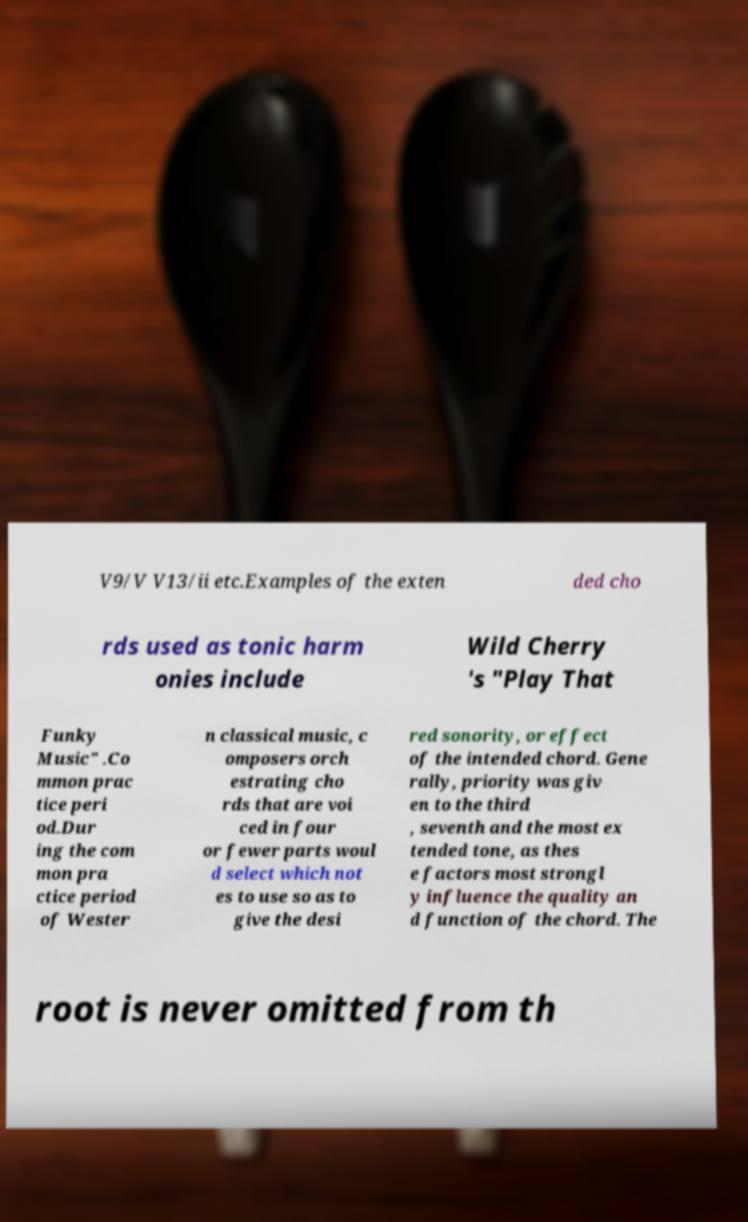What messages or text are displayed in this image? I need them in a readable, typed format. V9/V V13/ii etc.Examples of the exten ded cho rds used as tonic harm onies include Wild Cherry 's "Play That Funky Music" .Co mmon prac tice peri od.Dur ing the com mon pra ctice period of Wester n classical music, c omposers orch estrating cho rds that are voi ced in four or fewer parts woul d select which not es to use so as to give the desi red sonority, or effect of the intended chord. Gene rally, priority was giv en to the third , seventh and the most ex tended tone, as thes e factors most strongl y influence the quality an d function of the chord. The root is never omitted from th 